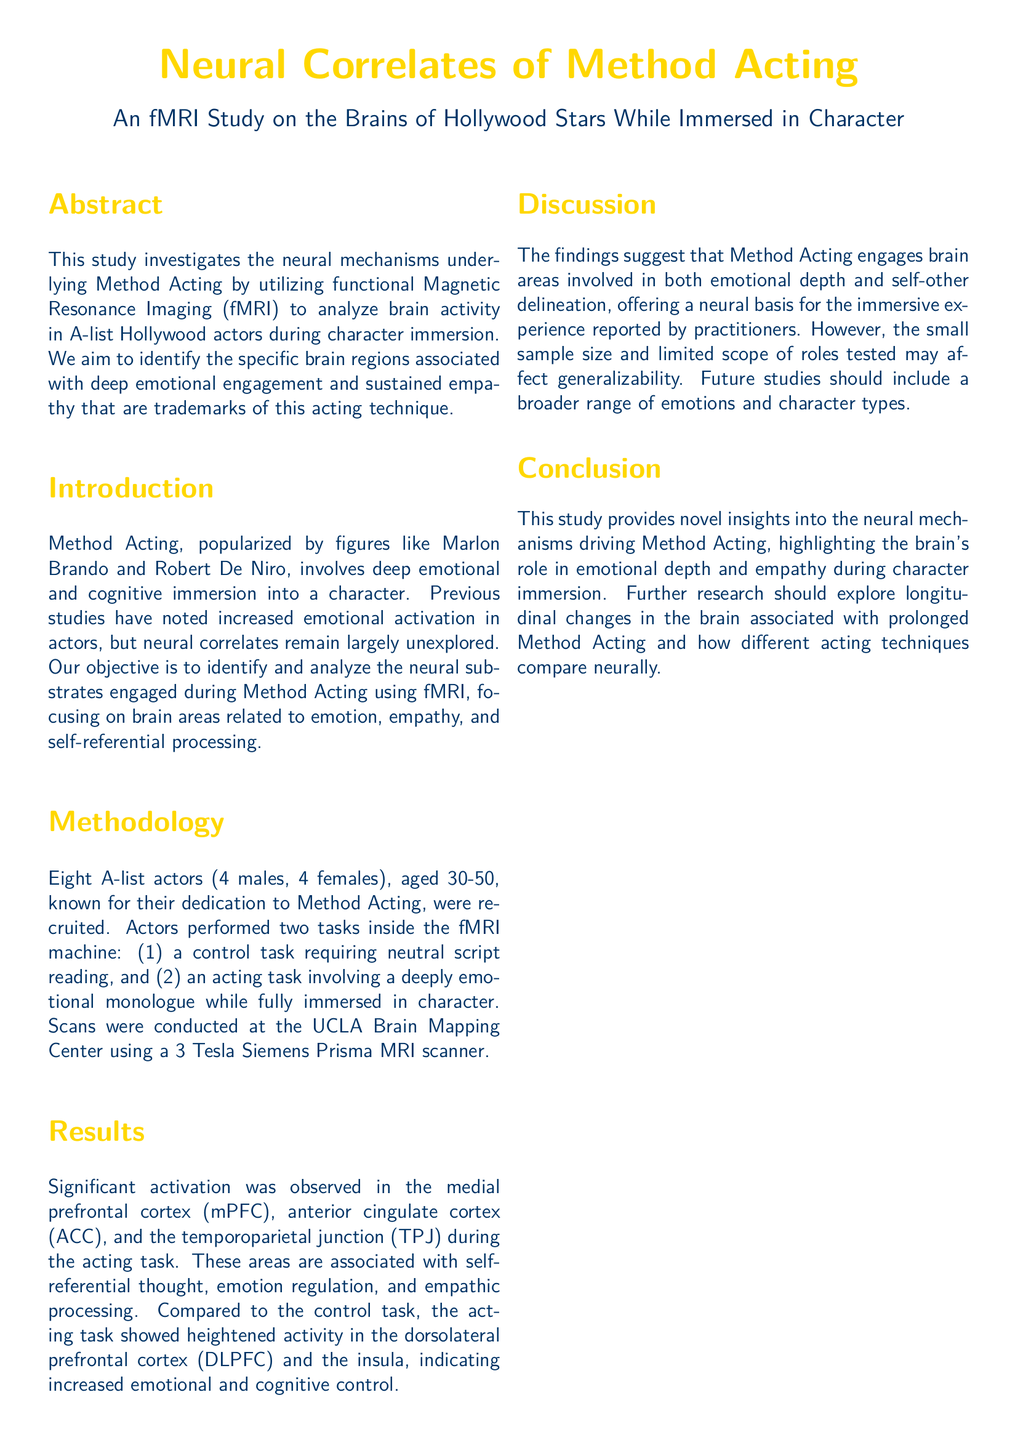What technique is investigated in the study? The study investigates the neural mechanisms underlying Method Acting.
Answer: Method Acting How many actors participated in the study? The document states that eight A-list actors were recruited for the study.
Answer: Eight What brain region showed significant activation during the acting task? The medial prefrontal cortex (mPFC) is identified as one of the regions with significant activation.
Answer: medial prefrontal cortex (mPFC) What is the age range of the actors involved in the study? The actors are specified to be aged between 30-50.
Answer: 30-50 What type of imaging technique was used in the study? The study utilized functional Magnetic Resonance Imaging (fMRI) for brain activity analysis.
Answer: fMRI Which brain area indicates increased emotional and cognitive control? The dorsolateral prefrontal cortex (DLPFC) showed increased activity during the acting task.
Answer: dorsolateral prefrontal cortex (DLPFC) What aspect of acting does the study aim to explore? The objective of the study is to analyze the neural substrates engaged during Method Acting.
Answer: neural substrates What limitation of the study is mentioned in the discussion? The authors note that the small sample size may affect generalizability.
Answer: small sample size What conclusion is drawn from the study? The study highlights the brain's role in emotional depth and empathy during character immersion.
Answer: emotional depth and empathy 